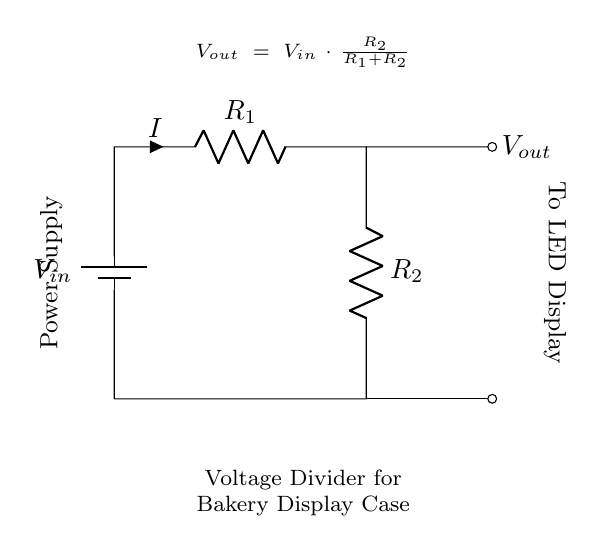What is the input voltage in this circuit? The input voltage, denoted as V_in, is the voltage supplied to the circuit and is typically provided from a power supply source connected at the top left of the diagram.
Answer: V_in What are the resistors in the circuit labeled? The resistors in the circuit are labeled as R_1 and R_2, positioned in a series arrangement to create the voltage divider. R_1 is located on the top branch, and R_2 is on the bottom branch.
Answer: R_1 and R_2 How is the output voltage calculated? The output voltage, V_out, is calculated using the formula displayed in the diagram: V_out = V_in multiplied by the ratio of R_2 over the sum of R_1 and R_2. This indicates how the resistors divide the input voltage proportionally.
Answer: V_out = V_in * (R_2 / (R_1 + R_2)) What will happen to the output voltage if R_2 is increased? Increasing R_2 will lead to a higher output voltage, according to the voltage divider principle, as the ratio of R_2 to the total resistance increases, allowing more of the input voltage to appear across R_2.
Answer: The output voltage increases What connects the two resistors in the circuit? The two resistors are connected in series, meaning the end of R_1 connects directly to the start of R_2, allowing the current to flow through both resistances consecutively.
Answer: Series connection How does increasing R_1 affect the current I? Increasing R_1 will reduce the current I flowing through the circuit, since a larger resistance in series restricts the flow of current according to Ohm's law, leading to a decrease in overall current for a fixed input voltage.
Answer: Current I decreases 